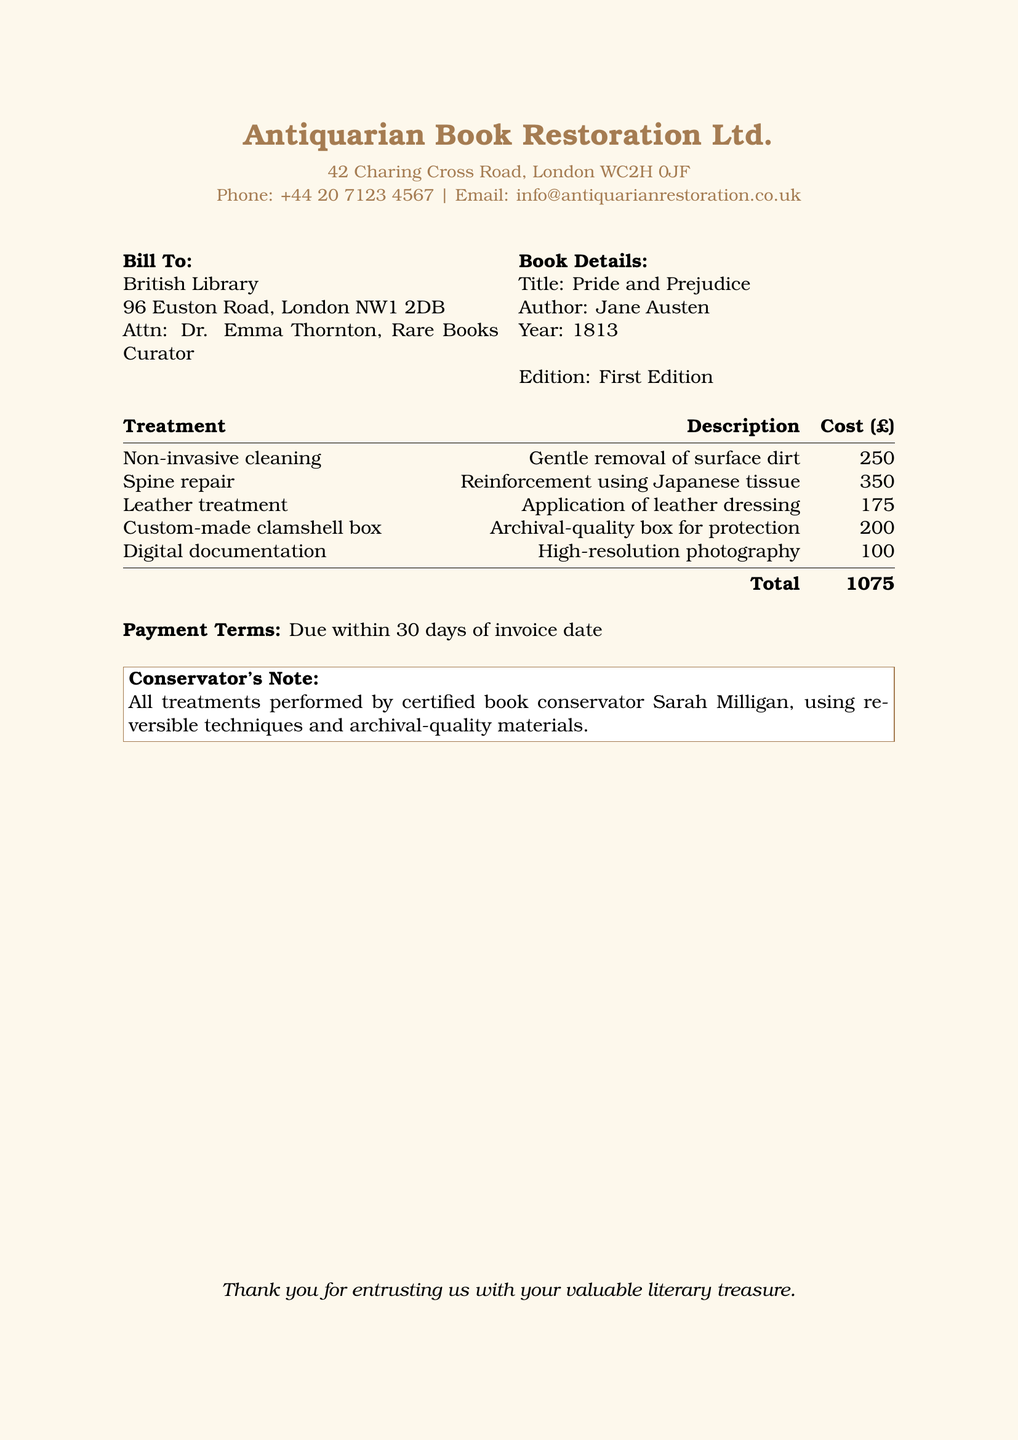what is the total cost of the conservation treatments? The total cost is the cumulative amount listed at the bottom of the invoice, which is £1075.
Answer: £1075 who is the conservator for this restoration? The conservator's name is provided in the conservator's note stating that Sarah Milligan performed all treatments.
Answer: Sarah Milligan what type of box was created for the book? The specific type of box mentioned in the invoice is a custom-made clamshell box used for the book's protection.
Answer: custom-made clamshell box how much was charged for leather treatment? The amount charged for leather treatment is stated in the treatment section of the document, specifically £175.
Answer: £175 what does the spine repair involve? The description listed explains the spine repair involves reinforcement using Japanese tissue.
Answer: reinforcement using Japanese tissue when is the payment due? The payment terms section specifies that payment is due within 30 days of the invoice date.
Answer: 30 days what is the address of Antiquarian Book Restoration Ltd.? The address is clearly provided in the header section of the invoice, specifically 42 Charing Cross Road, London WC2H 0JF.
Answer: 42 Charing Cross Road, London WC2H 0JF what is the title of the book being restored? The title of the book is listed under the book details, which is Pride and Prejudice.
Answer: Pride and Prejudice how much was charged for digital documentation? The cost for digital documentation is explicitly mentioned in the treatment section as £100.
Answer: £100 